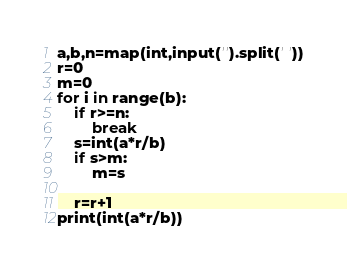Convert code to text. <code><loc_0><loc_0><loc_500><loc_500><_Python_>a,b,n=map(int,input('').split(' '))
r=0
m=0
for i in range(b):
    if r>=n:
        break
    s=int(a*r/b)
    if s>m:
        m=s
    
    r=r+1
print(int(a*r/b))</code> 